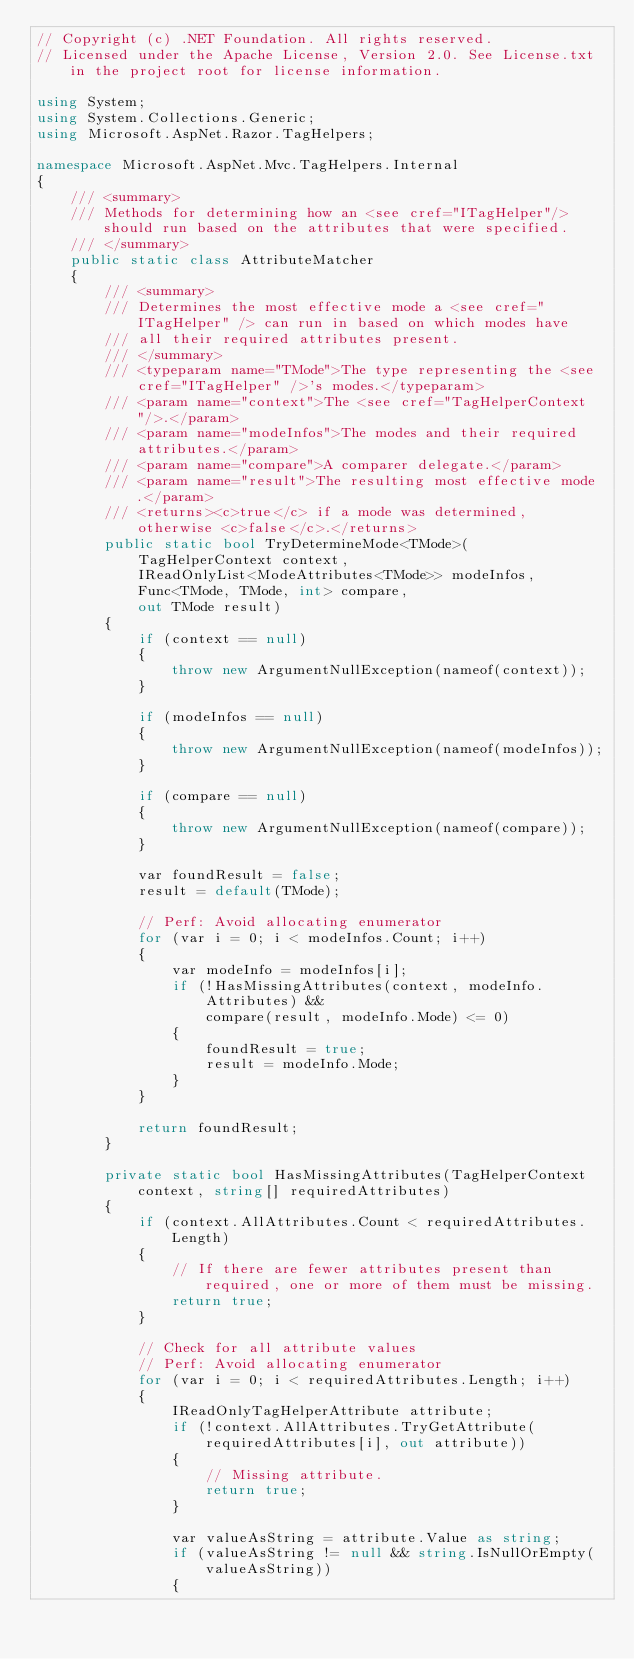Convert code to text. <code><loc_0><loc_0><loc_500><loc_500><_C#_>// Copyright (c) .NET Foundation. All rights reserved.
// Licensed under the Apache License, Version 2.0. See License.txt in the project root for license information.

using System;
using System.Collections.Generic;
using Microsoft.AspNet.Razor.TagHelpers;

namespace Microsoft.AspNet.Mvc.TagHelpers.Internal
{
    /// <summary>
    /// Methods for determining how an <see cref="ITagHelper"/> should run based on the attributes that were specified.
    /// </summary>
    public static class AttributeMatcher
    {
        /// <summary>
        /// Determines the most effective mode a <see cref="ITagHelper" /> can run in based on which modes have
        /// all their required attributes present.
        /// </summary>
        /// <typeparam name="TMode">The type representing the <see cref="ITagHelper" />'s modes.</typeparam>
        /// <param name="context">The <see cref="TagHelperContext"/>.</param>
        /// <param name="modeInfos">The modes and their required attributes.</param>
        /// <param name="compare">A comparer delegate.</param>
        /// <param name="result">The resulting most effective mode.</param>
        /// <returns><c>true</c> if a mode was determined, otherwise <c>false</c>.</returns>
        public static bool TryDetermineMode<TMode>(
            TagHelperContext context,
            IReadOnlyList<ModeAttributes<TMode>> modeInfos,
            Func<TMode, TMode, int> compare,
            out TMode result)
        {
            if (context == null)
            {
                throw new ArgumentNullException(nameof(context));
            }

            if (modeInfos == null)
            {
                throw new ArgumentNullException(nameof(modeInfos));
            }

            if (compare == null)
            {
                throw new ArgumentNullException(nameof(compare));
            }

            var foundResult = false;
            result = default(TMode);

            // Perf: Avoid allocating enumerator
            for (var i = 0; i < modeInfos.Count; i++)
            {
                var modeInfo = modeInfos[i];
                if (!HasMissingAttributes(context, modeInfo.Attributes) &&
                    compare(result, modeInfo.Mode) <= 0)
                {
                    foundResult = true;
                    result = modeInfo.Mode;
                }
            }

            return foundResult;
        }

        private static bool HasMissingAttributes(TagHelperContext context, string[] requiredAttributes)
        {
            if (context.AllAttributes.Count < requiredAttributes.Length)
            {
                // If there are fewer attributes present than required, one or more of them must be missing.
                return true;
            }

            // Check for all attribute values
            // Perf: Avoid allocating enumerator
            for (var i = 0; i < requiredAttributes.Length; i++)
            {
                IReadOnlyTagHelperAttribute attribute;
                if (!context.AllAttributes.TryGetAttribute(requiredAttributes[i], out attribute))
                {
                    // Missing attribute.
                    return true;
                }

                var valueAsString = attribute.Value as string;
                if (valueAsString != null && string.IsNullOrEmpty(valueAsString))
                {</code> 